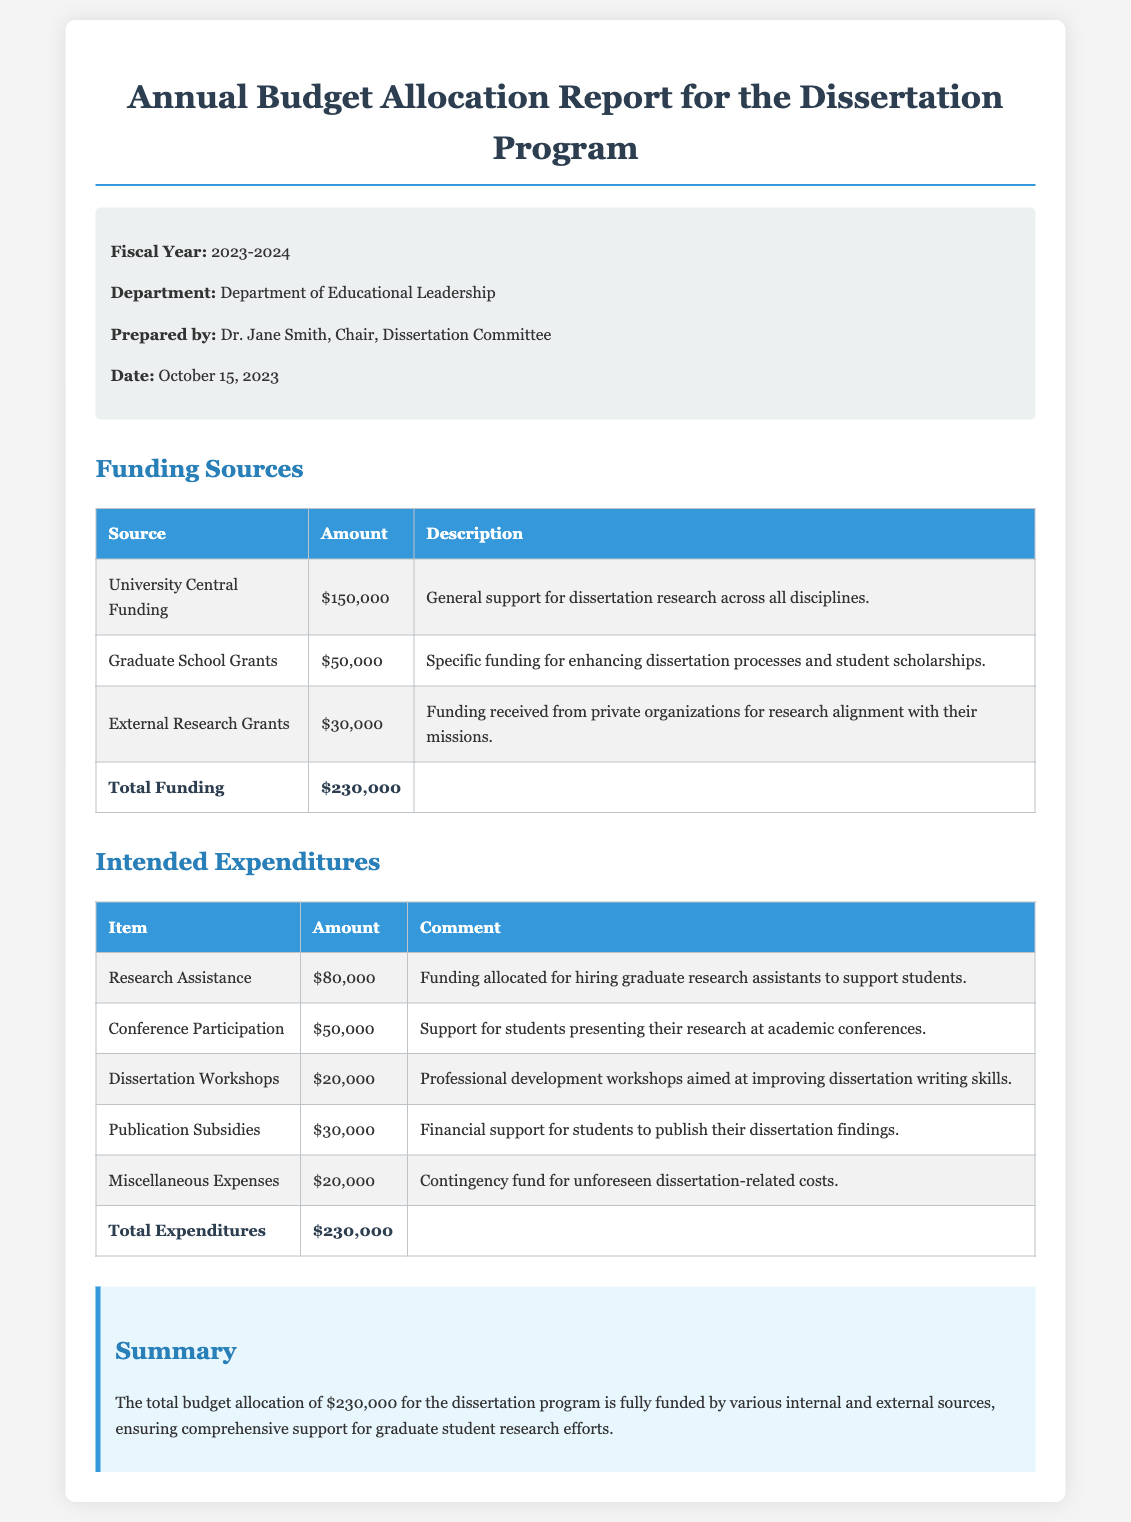What is the total funding allocated for the dissertation program? The total funding is presented at the end of the funding sources section, which states $230,000.
Answer: $230,000 What is the amount allocated for research assistance? The document specifies that $80,000 is allocated for hiring graduate research assistants.
Answer: $80,000 Who prepared the budget allocation report? The report indicates that it was prepared by Dr. Jane Smith, as stated in the meta-info section.
Answer: Dr. Jane Smith How much funding is received from external research grants? The amount listed under external research grants in the funding sources section is $30,000.
Answer: $30,000 What is the purpose of the miscellaneous expenses allocation? The document describes miscellaneous expenses as a contingency fund for unforeseen dissertation-related costs.
Answer: Contingency fund What is the total amount set aside for publication subsidies? The total amount for publication subsidies is noted in the intended expenditures table as $30,000.
Answer: $30,000 Which funding source provides the highest amount? The electronic document notes that University Central Funding contributes the most at $150,000.
Answer: University Central Funding When was the report prepared? The date of preparation is mentioned in the meta-info section as October 15, 2023.
Answer: October 15, 2023 How much is allocated for dissertation workshops? The allocation for dissertation workshops is specified in the intended expenditures table as $20,000.
Answer: $20,000 